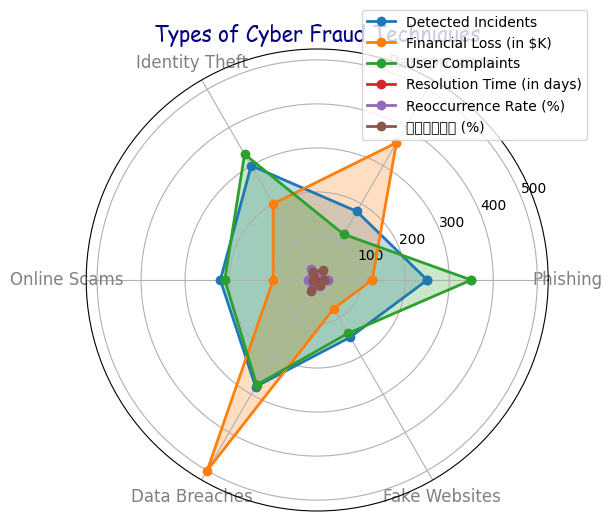Which cyber fraud technique has the highest number of detected incidents? By looking at the radar chart, we see that Identity Theft has the highest point on the "Detected Incidents" axis.
Answer: Identity Theft What's the difference in detected incidents between Phishing and Ransomware? The radar chart shows Phishing with 250 incidents and Ransomware with 180 incidents. The difference is 250 - 180 = 70.
Answer: 70 Which technique resulted in the highest financial loss? By examining the radar chart, Data Breaches have the highest value on the "Financial Loss (in $K)" axis.
Answer: Data Breaches Among the techniques, which one has the shortest resolution time? The radar chart shows the "Resolution Time (in days)" as lowest for Online Scams at 5 days.
Answer: Online Scams What is the average user complaints for Identity Theft and Data Breaches? The radar chart lists Identity Theft with 330 user complaints and Data Breaches with 275 complaints. The average is (330 + 275) / 2 = 302.5.
Answer: 302.5 How does the reoccurrence rate of Fake Websites compare to that of Phishing? The radar chart shows the reoccurrence rate for Fake Websites is 15% and for Phishing is 25%.
Answer: Fake Websites has a lower reoccurrence rate Which technique has the highest growth rate in recent years? The radar chart shows the "近年来增长率 (%)" is highest for Data Breaches at 30%.
Answer: Data Breaches If you combine the financial loss of Ransomware and Identity Theft, what is the total amount? The radar chart shows Ransomware with $360K and Identity Theft with $200K. The combined total is 360 + 200 = $560K.
Answer: $560K Compare the resolution time of Ransomware and Data Breaches. Which one takes longer? The radar chart shows the resolution time for Ransomware is 20 days, while for Data Breaches it is 15 days.
Answer: Ransomware What is the sum of user complaints for all techniques? Summing the values from the radar chart: 350 (Phishing) + 120 (Ransomware) + 330 (Identity Theft) + 210 (Online Scams) + 275 (Data Breaches) + 140 (Fake Websites) = 1425.
Answer: 1425 